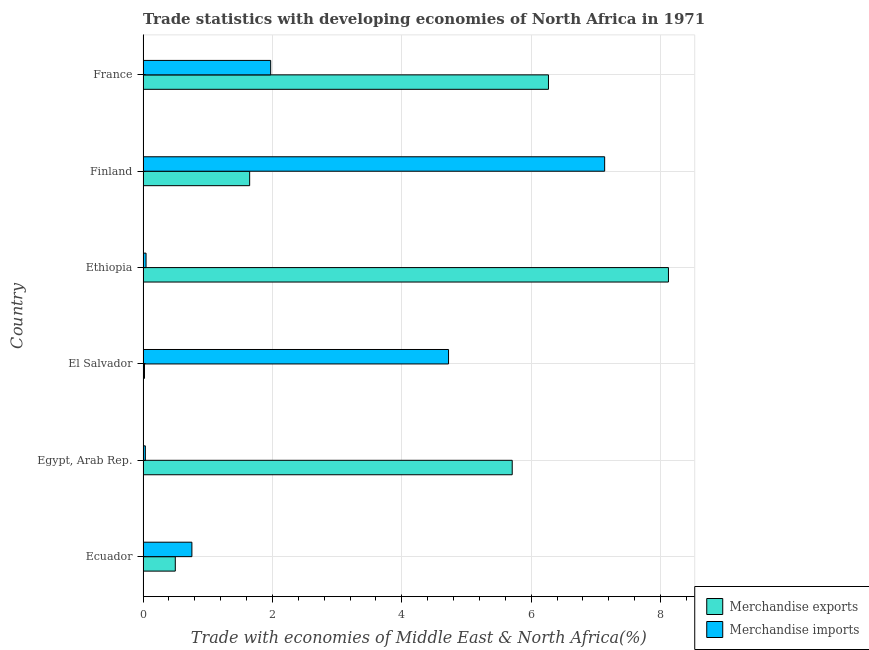How many groups of bars are there?
Offer a terse response. 6. Are the number of bars per tick equal to the number of legend labels?
Offer a very short reply. Yes. Are the number of bars on each tick of the Y-axis equal?
Make the answer very short. Yes. How many bars are there on the 2nd tick from the top?
Provide a short and direct response. 2. What is the merchandise imports in Egypt, Arab Rep.?
Keep it short and to the point. 0.04. Across all countries, what is the maximum merchandise exports?
Keep it short and to the point. 8.12. Across all countries, what is the minimum merchandise exports?
Provide a succinct answer. 0.02. In which country was the merchandise exports maximum?
Make the answer very short. Ethiopia. In which country was the merchandise imports minimum?
Offer a very short reply. Egypt, Arab Rep. What is the total merchandise exports in the graph?
Your response must be concise. 22.26. What is the difference between the merchandise exports in Egypt, Arab Rep. and that in Ethiopia?
Offer a terse response. -2.42. What is the difference between the merchandise exports in Ecuador and the merchandise imports in Egypt, Arab Rep.?
Make the answer very short. 0.46. What is the average merchandise imports per country?
Provide a succinct answer. 2.44. What is the difference between the merchandise imports and merchandise exports in Ecuador?
Keep it short and to the point. 0.26. What is the ratio of the merchandise exports in Egypt, Arab Rep. to that in Finland?
Keep it short and to the point. 3.46. What is the difference between the highest and the second highest merchandise exports?
Offer a terse response. 1.85. In how many countries, is the merchandise exports greater than the average merchandise exports taken over all countries?
Provide a short and direct response. 3. Is the sum of the merchandise exports in Ecuador and France greater than the maximum merchandise imports across all countries?
Your answer should be compact. No. What does the 1st bar from the top in Finland represents?
Offer a terse response. Merchandise imports. How many bars are there?
Your answer should be very brief. 12. Are all the bars in the graph horizontal?
Keep it short and to the point. Yes. How many countries are there in the graph?
Give a very brief answer. 6. What is the difference between two consecutive major ticks on the X-axis?
Make the answer very short. 2. Does the graph contain any zero values?
Ensure brevity in your answer.  No. Where does the legend appear in the graph?
Your response must be concise. Bottom right. How many legend labels are there?
Provide a short and direct response. 2. What is the title of the graph?
Give a very brief answer. Trade statistics with developing economies of North Africa in 1971. What is the label or title of the X-axis?
Your answer should be very brief. Trade with economies of Middle East & North Africa(%). What is the Trade with economies of Middle East & North Africa(%) in Merchandise exports in Ecuador?
Offer a very short reply. 0.5. What is the Trade with economies of Middle East & North Africa(%) of Merchandise imports in Ecuador?
Ensure brevity in your answer.  0.75. What is the Trade with economies of Middle East & North Africa(%) of Merchandise exports in Egypt, Arab Rep.?
Give a very brief answer. 5.71. What is the Trade with economies of Middle East & North Africa(%) in Merchandise imports in Egypt, Arab Rep.?
Provide a short and direct response. 0.04. What is the Trade with economies of Middle East & North Africa(%) of Merchandise exports in El Salvador?
Give a very brief answer. 0.02. What is the Trade with economies of Middle East & North Africa(%) in Merchandise imports in El Salvador?
Provide a short and direct response. 4.72. What is the Trade with economies of Middle East & North Africa(%) of Merchandise exports in Ethiopia?
Your answer should be compact. 8.12. What is the Trade with economies of Middle East & North Africa(%) of Merchandise imports in Ethiopia?
Your response must be concise. 0.05. What is the Trade with economies of Middle East & North Africa(%) in Merchandise exports in Finland?
Make the answer very short. 1.65. What is the Trade with economies of Middle East & North Africa(%) in Merchandise imports in Finland?
Ensure brevity in your answer.  7.13. What is the Trade with economies of Middle East & North Africa(%) in Merchandise exports in France?
Your response must be concise. 6.27. What is the Trade with economies of Middle East & North Africa(%) of Merchandise imports in France?
Your response must be concise. 1.97. Across all countries, what is the maximum Trade with economies of Middle East & North Africa(%) of Merchandise exports?
Provide a succinct answer. 8.12. Across all countries, what is the maximum Trade with economies of Middle East & North Africa(%) of Merchandise imports?
Keep it short and to the point. 7.13. Across all countries, what is the minimum Trade with economies of Middle East & North Africa(%) in Merchandise exports?
Provide a short and direct response. 0.02. Across all countries, what is the minimum Trade with economies of Middle East & North Africa(%) in Merchandise imports?
Keep it short and to the point. 0.04. What is the total Trade with economies of Middle East & North Africa(%) in Merchandise exports in the graph?
Offer a terse response. 22.26. What is the total Trade with economies of Middle East & North Africa(%) in Merchandise imports in the graph?
Offer a terse response. 14.67. What is the difference between the Trade with economies of Middle East & North Africa(%) of Merchandise exports in Ecuador and that in Egypt, Arab Rep.?
Offer a terse response. -5.21. What is the difference between the Trade with economies of Middle East & North Africa(%) in Merchandise imports in Ecuador and that in Egypt, Arab Rep.?
Your answer should be compact. 0.72. What is the difference between the Trade with economies of Middle East & North Africa(%) of Merchandise exports in Ecuador and that in El Salvador?
Provide a short and direct response. 0.48. What is the difference between the Trade with economies of Middle East & North Africa(%) of Merchandise imports in Ecuador and that in El Salvador?
Offer a very short reply. -3.97. What is the difference between the Trade with economies of Middle East & North Africa(%) in Merchandise exports in Ecuador and that in Ethiopia?
Ensure brevity in your answer.  -7.62. What is the difference between the Trade with economies of Middle East & North Africa(%) of Merchandise imports in Ecuador and that in Ethiopia?
Make the answer very short. 0.71. What is the difference between the Trade with economies of Middle East & North Africa(%) in Merchandise exports in Ecuador and that in Finland?
Provide a short and direct response. -1.15. What is the difference between the Trade with economies of Middle East & North Africa(%) in Merchandise imports in Ecuador and that in Finland?
Your response must be concise. -6.38. What is the difference between the Trade with economies of Middle East & North Africa(%) in Merchandise exports in Ecuador and that in France?
Give a very brief answer. -5.77. What is the difference between the Trade with economies of Middle East & North Africa(%) in Merchandise imports in Ecuador and that in France?
Make the answer very short. -1.22. What is the difference between the Trade with economies of Middle East & North Africa(%) of Merchandise exports in Egypt, Arab Rep. and that in El Salvador?
Keep it short and to the point. 5.68. What is the difference between the Trade with economies of Middle East & North Africa(%) in Merchandise imports in Egypt, Arab Rep. and that in El Salvador?
Keep it short and to the point. -4.69. What is the difference between the Trade with economies of Middle East & North Africa(%) in Merchandise exports in Egypt, Arab Rep. and that in Ethiopia?
Give a very brief answer. -2.42. What is the difference between the Trade with economies of Middle East & North Africa(%) of Merchandise imports in Egypt, Arab Rep. and that in Ethiopia?
Ensure brevity in your answer.  -0.01. What is the difference between the Trade with economies of Middle East & North Africa(%) of Merchandise exports in Egypt, Arab Rep. and that in Finland?
Provide a succinct answer. 4.06. What is the difference between the Trade with economies of Middle East & North Africa(%) in Merchandise imports in Egypt, Arab Rep. and that in Finland?
Your response must be concise. -7.1. What is the difference between the Trade with economies of Middle East & North Africa(%) of Merchandise exports in Egypt, Arab Rep. and that in France?
Give a very brief answer. -0.56. What is the difference between the Trade with economies of Middle East & North Africa(%) of Merchandise imports in Egypt, Arab Rep. and that in France?
Your answer should be compact. -1.94. What is the difference between the Trade with economies of Middle East & North Africa(%) of Merchandise exports in El Salvador and that in Ethiopia?
Make the answer very short. -8.1. What is the difference between the Trade with economies of Middle East & North Africa(%) in Merchandise imports in El Salvador and that in Ethiopia?
Offer a very short reply. 4.68. What is the difference between the Trade with economies of Middle East & North Africa(%) of Merchandise exports in El Salvador and that in Finland?
Ensure brevity in your answer.  -1.63. What is the difference between the Trade with economies of Middle East & North Africa(%) of Merchandise imports in El Salvador and that in Finland?
Provide a short and direct response. -2.41. What is the difference between the Trade with economies of Middle East & North Africa(%) of Merchandise exports in El Salvador and that in France?
Provide a short and direct response. -6.24. What is the difference between the Trade with economies of Middle East & North Africa(%) in Merchandise imports in El Salvador and that in France?
Ensure brevity in your answer.  2.75. What is the difference between the Trade with economies of Middle East & North Africa(%) of Merchandise exports in Ethiopia and that in Finland?
Give a very brief answer. 6.47. What is the difference between the Trade with economies of Middle East & North Africa(%) in Merchandise imports in Ethiopia and that in Finland?
Provide a short and direct response. -7.09. What is the difference between the Trade with economies of Middle East & North Africa(%) of Merchandise exports in Ethiopia and that in France?
Offer a very short reply. 1.85. What is the difference between the Trade with economies of Middle East & North Africa(%) in Merchandise imports in Ethiopia and that in France?
Provide a short and direct response. -1.93. What is the difference between the Trade with economies of Middle East & North Africa(%) in Merchandise exports in Finland and that in France?
Give a very brief answer. -4.62. What is the difference between the Trade with economies of Middle East & North Africa(%) of Merchandise imports in Finland and that in France?
Offer a terse response. 5.16. What is the difference between the Trade with economies of Middle East & North Africa(%) in Merchandise exports in Ecuador and the Trade with economies of Middle East & North Africa(%) in Merchandise imports in Egypt, Arab Rep.?
Your answer should be compact. 0.46. What is the difference between the Trade with economies of Middle East & North Africa(%) of Merchandise exports in Ecuador and the Trade with economies of Middle East & North Africa(%) of Merchandise imports in El Salvador?
Your answer should be compact. -4.22. What is the difference between the Trade with economies of Middle East & North Africa(%) in Merchandise exports in Ecuador and the Trade with economies of Middle East & North Africa(%) in Merchandise imports in Ethiopia?
Offer a terse response. 0.45. What is the difference between the Trade with economies of Middle East & North Africa(%) in Merchandise exports in Ecuador and the Trade with economies of Middle East & North Africa(%) in Merchandise imports in Finland?
Offer a terse response. -6.64. What is the difference between the Trade with economies of Middle East & North Africa(%) of Merchandise exports in Ecuador and the Trade with economies of Middle East & North Africa(%) of Merchandise imports in France?
Keep it short and to the point. -1.47. What is the difference between the Trade with economies of Middle East & North Africa(%) in Merchandise exports in Egypt, Arab Rep. and the Trade with economies of Middle East & North Africa(%) in Merchandise imports in Ethiopia?
Keep it short and to the point. 5.66. What is the difference between the Trade with economies of Middle East & North Africa(%) in Merchandise exports in Egypt, Arab Rep. and the Trade with economies of Middle East & North Africa(%) in Merchandise imports in Finland?
Ensure brevity in your answer.  -1.43. What is the difference between the Trade with economies of Middle East & North Africa(%) in Merchandise exports in Egypt, Arab Rep. and the Trade with economies of Middle East & North Africa(%) in Merchandise imports in France?
Provide a short and direct response. 3.73. What is the difference between the Trade with economies of Middle East & North Africa(%) in Merchandise exports in El Salvador and the Trade with economies of Middle East & North Africa(%) in Merchandise imports in Ethiopia?
Offer a very short reply. -0.02. What is the difference between the Trade with economies of Middle East & North Africa(%) of Merchandise exports in El Salvador and the Trade with economies of Middle East & North Africa(%) of Merchandise imports in Finland?
Your answer should be very brief. -7.11. What is the difference between the Trade with economies of Middle East & North Africa(%) in Merchandise exports in El Salvador and the Trade with economies of Middle East & North Africa(%) in Merchandise imports in France?
Offer a terse response. -1.95. What is the difference between the Trade with economies of Middle East & North Africa(%) in Merchandise exports in Ethiopia and the Trade with economies of Middle East & North Africa(%) in Merchandise imports in Finland?
Offer a very short reply. 0.99. What is the difference between the Trade with economies of Middle East & North Africa(%) in Merchandise exports in Ethiopia and the Trade with economies of Middle East & North Africa(%) in Merchandise imports in France?
Make the answer very short. 6.15. What is the difference between the Trade with economies of Middle East & North Africa(%) in Merchandise exports in Finland and the Trade with economies of Middle East & North Africa(%) in Merchandise imports in France?
Make the answer very short. -0.33. What is the average Trade with economies of Middle East & North Africa(%) in Merchandise exports per country?
Offer a very short reply. 3.71. What is the average Trade with economies of Middle East & North Africa(%) in Merchandise imports per country?
Offer a very short reply. 2.44. What is the difference between the Trade with economies of Middle East & North Africa(%) in Merchandise exports and Trade with economies of Middle East & North Africa(%) in Merchandise imports in Ecuador?
Provide a short and direct response. -0.26. What is the difference between the Trade with economies of Middle East & North Africa(%) of Merchandise exports and Trade with economies of Middle East & North Africa(%) of Merchandise imports in Egypt, Arab Rep.?
Offer a very short reply. 5.67. What is the difference between the Trade with economies of Middle East & North Africa(%) in Merchandise exports and Trade with economies of Middle East & North Africa(%) in Merchandise imports in El Salvador?
Make the answer very short. -4.7. What is the difference between the Trade with economies of Middle East & North Africa(%) in Merchandise exports and Trade with economies of Middle East & North Africa(%) in Merchandise imports in Ethiopia?
Your response must be concise. 8.07. What is the difference between the Trade with economies of Middle East & North Africa(%) of Merchandise exports and Trade with economies of Middle East & North Africa(%) of Merchandise imports in Finland?
Offer a terse response. -5.49. What is the difference between the Trade with economies of Middle East & North Africa(%) in Merchandise exports and Trade with economies of Middle East & North Africa(%) in Merchandise imports in France?
Your answer should be compact. 4.29. What is the ratio of the Trade with economies of Middle East & North Africa(%) of Merchandise exports in Ecuador to that in Egypt, Arab Rep.?
Offer a very short reply. 0.09. What is the ratio of the Trade with economies of Middle East & North Africa(%) of Merchandise imports in Ecuador to that in Egypt, Arab Rep.?
Make the answer very short. 21.46. What is the ratio of the Trade with economies of Middle East & North Africa(%) in Merchandise exports in Ecuador to that in El Salvador?
Provide a short and direct response. 22.6. What is the ratio of the Trade with economies of Middle East & North Africa(%) in Merchandise imports in Ecuador to that in El Salvador?
Your answer should be very brief. 0.16. What is the ratio of the Trade with economies of Middle East & North Africa(%) in Merchandise exports in Ecuador to that in Ethiopia?
Provide a succinct answer. 0.06. What is the ratio of the Trade with economies of Middle East & North Africa(%) of Merchandise imports in Ecuador to that in Ethiopia?
Your answer should be compact. 16.4. What is the ratio of the Trade with economies of Middle East & North Africa(%) of Merchandise exports in Ecuador to that in Finland?
Keep it short and to the point. 0.3. What is the ratio of the Trade with economies of Middle East & North Africa(%) of Merchandise imports in Ecuador to that in Finland?
Keep it short and to the point. 0.11. What is the ratio of the Trade with economies of Middle East & North Africa(%) in Merchandise exports in Ecuador to that in France?
Provide a short and direct response. 0.08. What is the ratio of the Trade with economies of Middle East & North Africa(%) of Merchandise imports in Ecuador to that in France?
Give a very brief answer. 0.38. What is the ratio of the Trade with economies of Middle East & North Africa(%) in Merchandise exports in Egypt, Arab Rep. to that in El Salvador?
Keep it short and to the point. 258.81. What is the ratio of the Trade with economies of Middle East & North Africa(%) of Merchandise imports in Egypt, Arab Rep. to that in El Salvador?
Keep it short and to the point. 0.01. What is the ratio of the Trade with economies of Middle East & North Africa(%) in Merchandise exports in Egypt, Arab Rep. to that in Ethiopia?
Your answer should be very brief. 0.7. What is the ratio of the Trade with economies of Middle East & North Africa(%) of Merchandise imports in Egypt, Arab Rep. to that in Ethiopia?
Offer a terse response. 0.76. What is the ratio of the Trade with economies of Middle East & North Africa(%) of Merchandise exports in Egypt, Arab Rep. to that in Finland?
Your answer should be very brief. 3.46. What is the ratio of the Trade with economies of Middle East & North Africa(%) of Merchandise imports in Egypt, Arab Rep. to that in Finland?
Your answer should be compact. 0. What is the ratio of the Trade with economies of Middle East & North Africa(%) in Merchandise exports in Egypt, Arab Rep. to that in France?
Offer a terse response. 0.91. What is the ratio of the Trade with economies of Middle East & North Africa(%) in Merchandise imports in Egypt, Arab Rep. to that in France?
Your answer should be very brief. 0.02. What is the ratio of the Trade with economies of Middle East & North Africa(%) of Merchandise exports in El Salvador to that in Ethiopia?
Your answer should be very brief. 0. What is the ratio of the Trade with economies of Middle East & North Africa(%) in Merchandise imports in El Salvador to that in Ethiopia?
Make the answer very short. 102.58. What is the ratio of the Trade with economies of Middle East & North Africa(%) in Merchandise exports in El Salvador to that in Finland?
Your answer should be compact. 0.01. What is the ratio of the Trade with economies of Middle East & North Africa(%) in Merchandise imports in El Salvador to that in Finland?
Your answer should be compact. 0.66. What is the ratio of the Trade with economies of Middle East & North Africa(%) in Merchandise exports in El Salvador to that in France?
Offer a terse response. 0. What is the ratio of the Trade with economies of Middle East & North Africa(%) of Merchandise imports in El Salvador to that in France?
Ensure brevity in your answer.  2.39. What is the ratio of the Trade with economies of Middle East & North Africa(%) of Merchandise exports in Ethiopia to that in Finland?
Make the answer very short. 4.93. What is the ratio of the Trade with economies of Middle East & North Africa(%) in Merchandise imports in Ethiopia to that in Finland?
Ensure brevity in your answer.  0.01. What is the ratio of the Trade with economies of Middle East & North Africa(%) of Merchandise exports in Ethiopia to that in France?
Your response must be concise. 1.3. What is the ratio of the Trade with economies of Middle East & North Africa(%) in Merchandise imports in Ethiopia to that in France?
Give a very brief answer. 0.02. What is the ratio of the Trade with economies of Middle East & North Africa(%) of Merchandise exports in Finland to that in France?
Your answer should be compact. 0.26. What is the ratio of the Trade with economies of Middle East & North Africa(%) of Merchandise imports in Finland to that in France?
Provide a short and direct response. 3.62. What is the difference between the highest and the second highest Trade with economies of Middle East & North Africa(%) in Merchandise exports?
Make the answer very short. 1.85. What is the difference between the highest and the second highest Trade with economies of Middle East & North Africa(%) of Merchandise imports?
Ensure brevity in your answer.  2.41. What is the difference between the highest and the lowest Trade with economies of Middle East & North Africa(%) of Merchandise exports?
Your response must be concise. 8.1. What is the difference between the highest and the lowest Trade with economies of Middle East & North Africa(%) in Merchandise imports?
Your response must be concise. 7.1. 